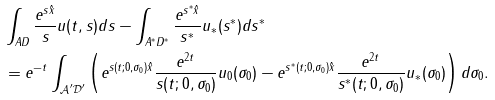<formula> <loc_0><loc_0><loc_500><loc_500>& \int _ { A D } \frac { e ^ { s \hat { x } } } { s } u ( t , s ) d s - \int _ { A ^ { * } D ^ { * } } \frac { e ^ { s ^ { * } \hat { x } } } { s ^ { * } } u _ { * } ( s ^ { * } ) d s ^ { * } \\ & = e ^ { - t } \int _ { \mathcal { A } ^ { \prime } \mathcal { D } ^ { \prime } } \left ( e ^ { s ( t ; 0 , \sigma _ { 0 } ) \hat { x } } \frac { e ^ { 2 t } } { s ( t ; 0 , \sigma _ { 0 } ) } u _ { 0 } ( \sigma _ { 0 } ) - e ^ { s ^ { * } ( t ; 0 , \sigma _ { 0 } ) \hat { x } } \frac { e ^ { 2 t } } { s ^ { * } ( t ; 0 , \sigma _ { 0 } ) } u _ { * } ( \sigma _ { 0 } ) \right ) d \sigma _ { 0 } .</formula> 